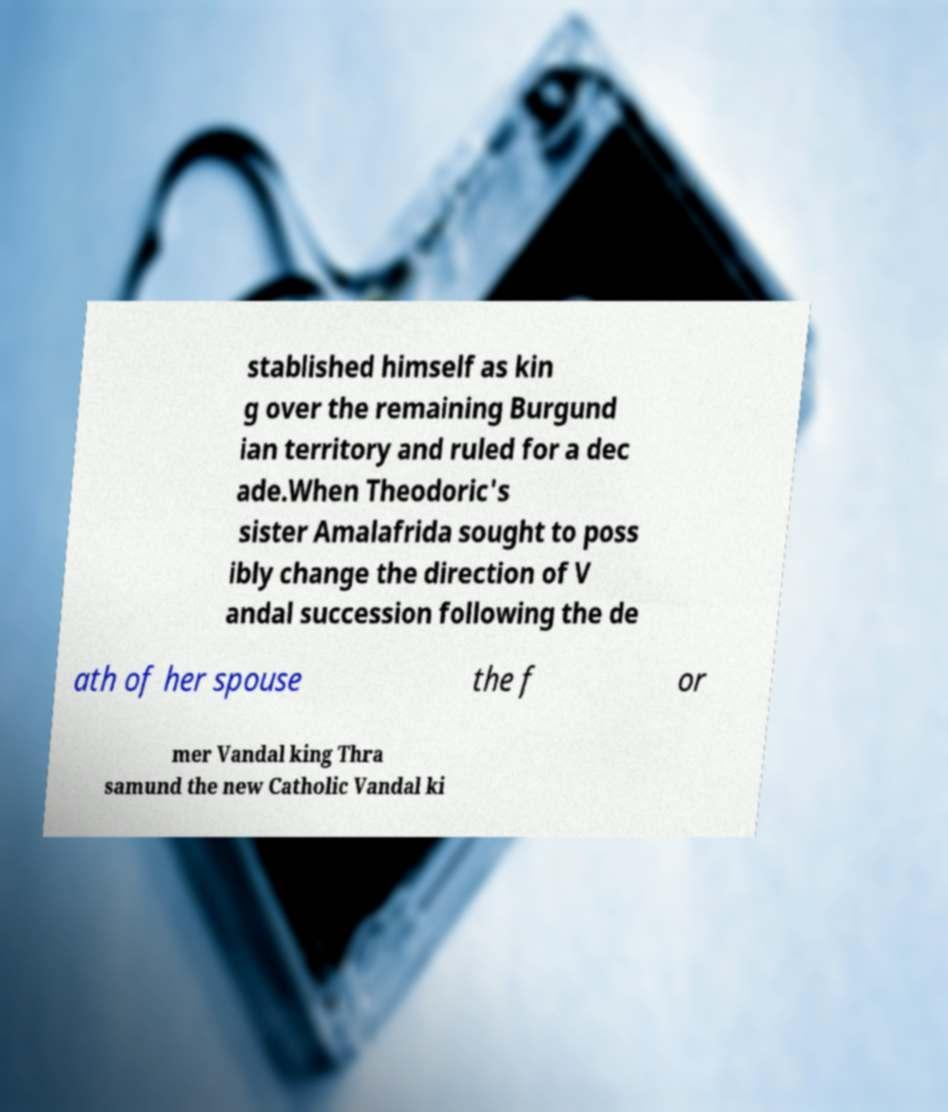Please identify and transcribe the text found in this image. stablished himself as kin g over the remaining Burgund ian territory and ruled for a dec ade.When Theodoric's sister Amalafrida sought to poss ibly change the direction of V andal succession following the de ath of her spouse the f or mer Vandal king Thra samund the new Catholic Vandal ki 